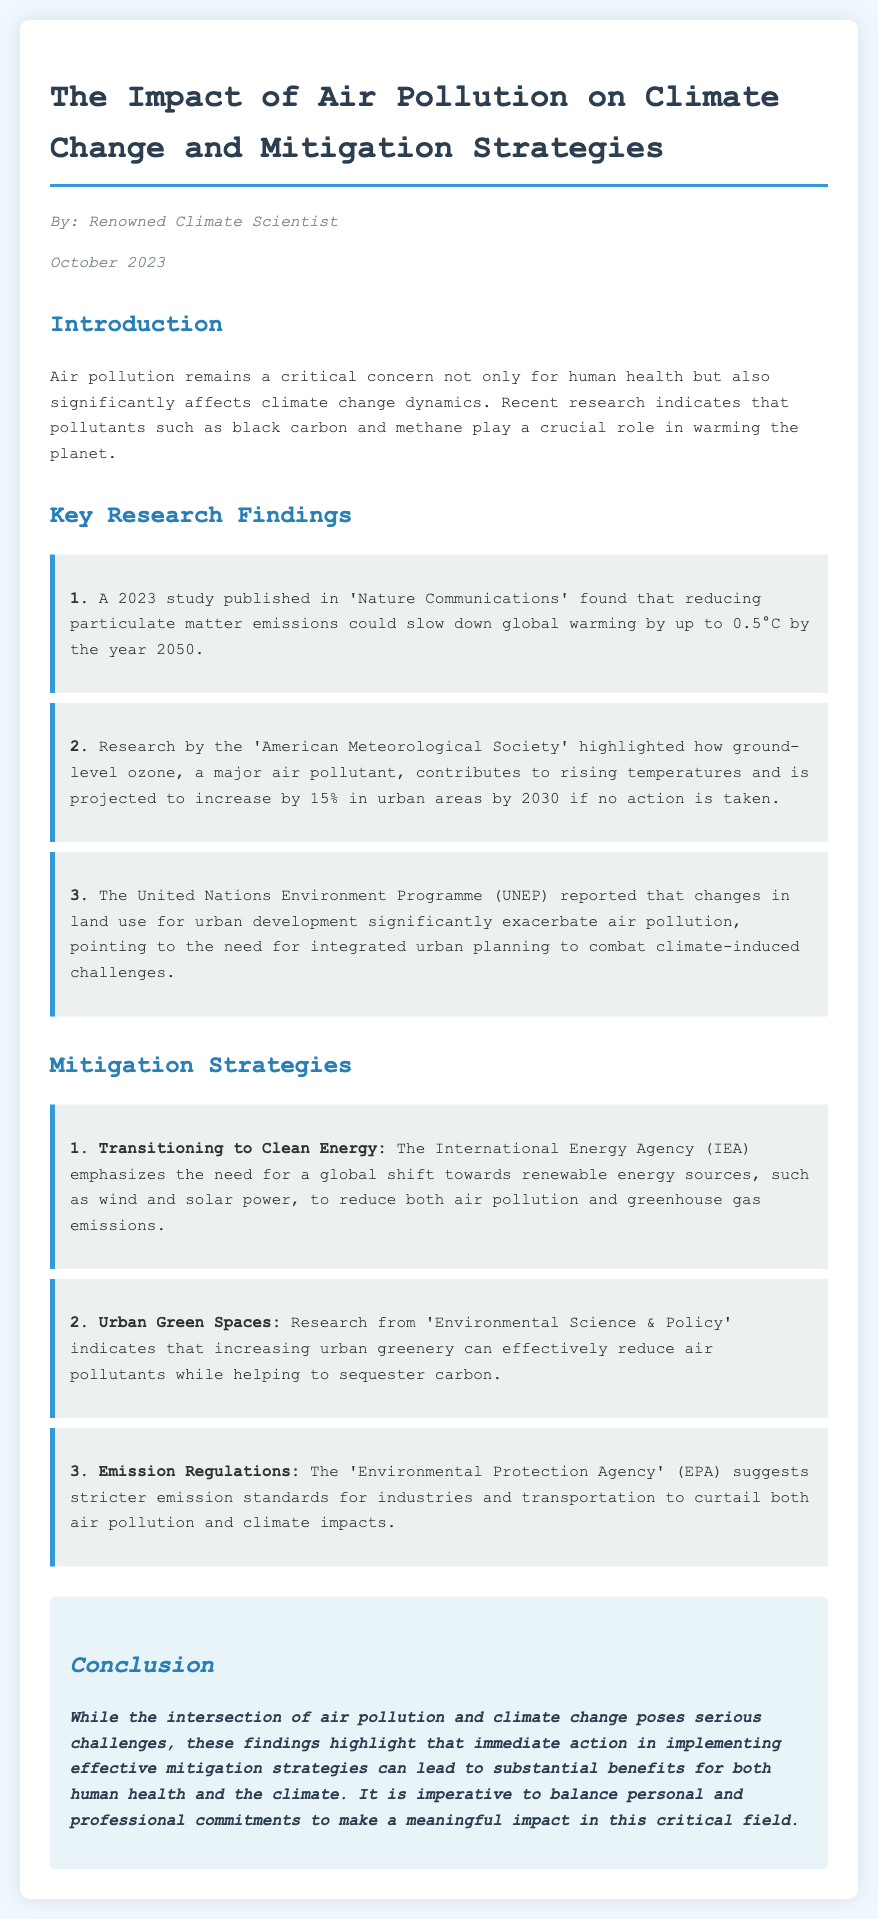What is the title of the document? The title is explicitly mentioned at the beginning of the document.
Answer: The Impact of Air Pollution on Climate Change and Mitigation Strategies Who authored the document? The author is specified in the document and is described as a renowned climate scientist.
Answer: Renowned Climate Scientist What critical role do pollutants like black carbon and methane play? The text explains that these pollutants affect climate change dynamics.
Answer: Warming the planet By how much could reducing particulate matter emissions slow global warming by 2050? This specific figure is provided in the key research findings section.
Answer: Up to 0.5°C What organization reported on land use changes exacerbating air pollution? The document references a specific organization related to this finding.
Answer: United Nations Environment Programme (UNEP) What is one of the mitigation strategies highlighted? The document lists several mitigation strategies, providing insight into effective actions.
Answer: Transitioning to Clean Energy What is projected to increase by 15% in urban areas by 2030? The document includes this specific projection related to an air pollutant.
Answer: Ground-level ozone According to the Environmental Protection Agency, what is suggested for industries? The document provides suggestions from this agency as part of mitigation strategies.
Answer: Stricter emission standards 